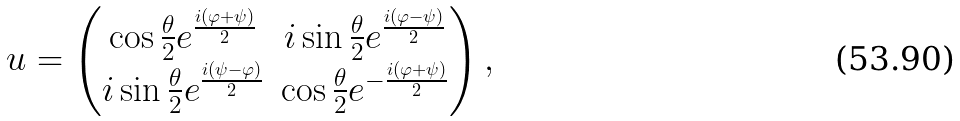<formula> <loc_0><loc_0><loc_500><loc_500>u = \begin{pmatrix} \cos \frac { \theta } { 2 } e ^ { \frac { i ( \varphi + \psi ) } { 2 } } & i \sin \frac { \theta } { 2 } e ^ { \frac { i ( \varphi - \psi ) } { 2 } } \\ i \sin \frac { \theta } { 2 } e ^ { \frac { i ( \psi - \varphi ) } { 2 } } & \cos \frac { \theta } { 2 } e ^ { - \frac { i ( \varphi + \psi ) } { 2 } } \end{pmatrix} ,</formula> 